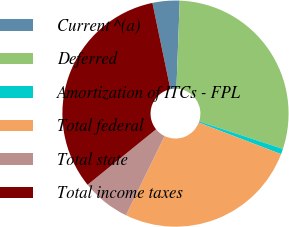Convert chart to OTSL. <chart><loc_0><loc_0><loc_500><loc_500><pie_chart><fcel>Current ^(a)<fcel>Deferred<fcel>Amortization of ITCs - FPL<fcel>Total federal<fcel>Total state<fcel>Total income taxes<nl><fcel>3.87%<fcel>29.46%<fcel>0.78%<fcel>26.37%<fcel>6.96%<fcel>32.56%<nl></chart> 